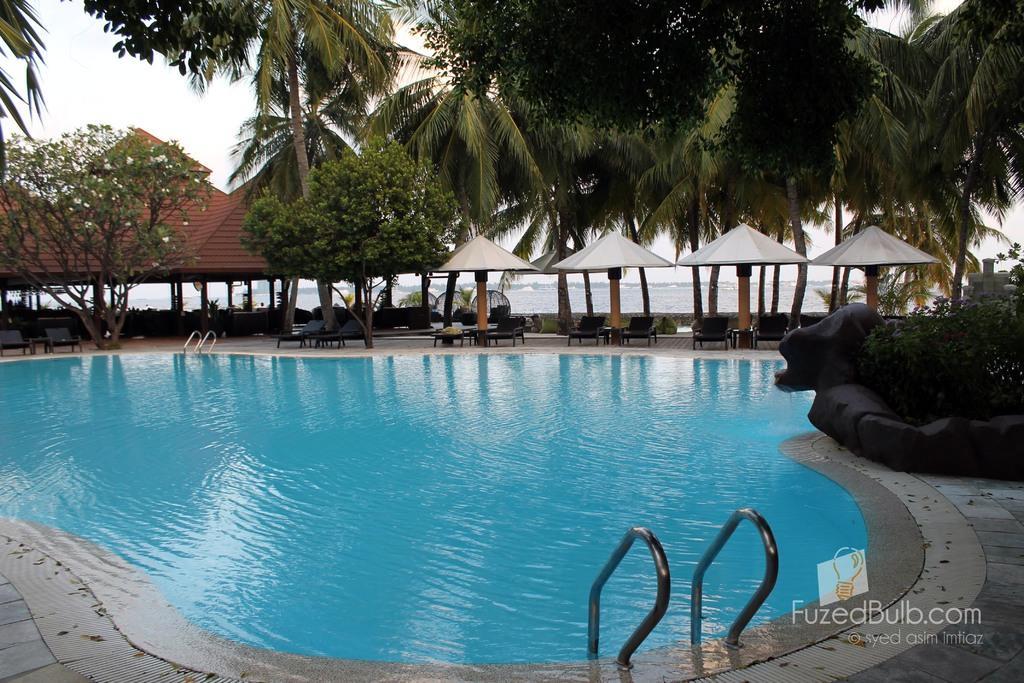Can you describe this image briefly? In the foreground of this picture, there is a swimming pool. In the background, there are umbrellas, chairs, trees, shed and the sky. 